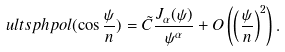Convert formula to latex. <formula><loc_0><loc_0><loc_500><loc_500>\ u l t s p h p o l ( \cos { \frac { \psi } { n } } ) = \tilde { C } \frac { J _ { \alpha } ( \psi ) } { \psi ^ { \alpha } } + O \left ( \left ( \frac { \psi } { n } \right ) ^ { 2 } \right ) .</formula> 